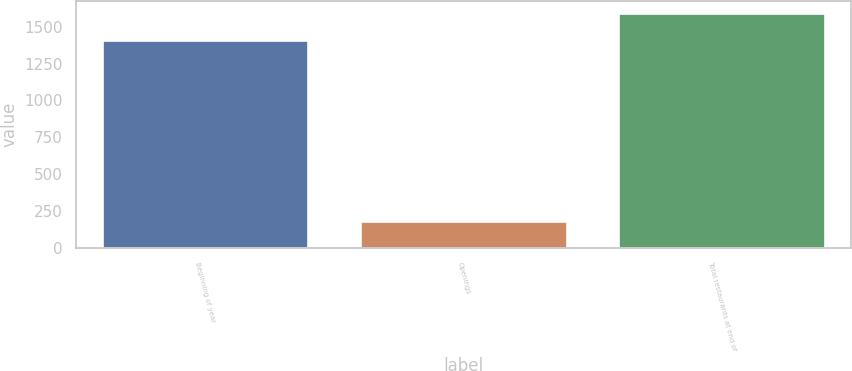Convert chart to OTSL. <chart><loc_0><loc_0><loc_500><loc_500><bar_chart><fcel>Beginning of year<fcel>Openings<fcel>Total restaurants at end of<nl><fcel>1410<fcel>185<fcel>1595<nl></chart> 